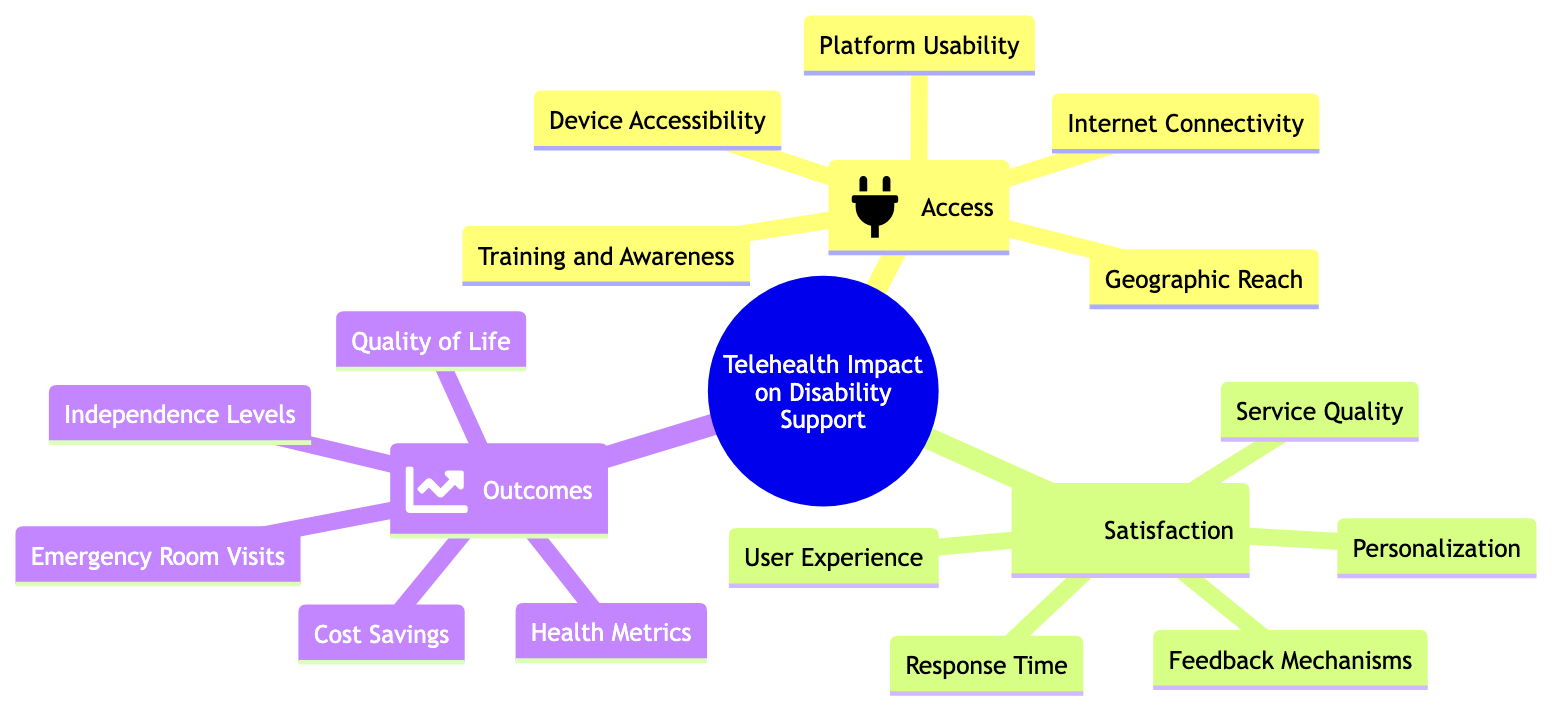What is the main topic of the mind map? The main topic is found at the root of the diagram, which states "Analyzing the Impact of Telehealth Solutions on Disability Support."
Answer: Analyzing the Impact of Telehealth Solutions on Disability Support How many subtopics are there under the main topic? There are three distinct subtopics branching from the main topic: "Access," "Satisfaction," and "Outcomes." Thus, by counting these subtopics, we determine there are three.
Answer: 3 What element is listed under the "Access" subtopic? Looking under the "Access" subtopic, the first element mentioned is "Internet Connectivity."
Answer: Internet Connectivity Which subtopic has the most elements listed? By examining each subtopic and counting their respective elements, we find that both "Access" and "Satisfaction" have five elements, while "Outcomes" has four. Therefore, "Access" and "Satisfaction" are tied for the most elements.
Answer: Access and Satisfaction What is the last element listed under the "Outcomes" subtopic? In the "Outcomes" section of the diagram, the last element listed is "Cost Savings."
Answer: Cost Savings How do "User Experience" and "Service Quality" relate in the satisfaction subtopic? Both "User Experience" and "Service Quality" are elements under the same subtopic "Satisfaction," indicating they are components contributing to the overall satisfaction level.
Answer: Related elements Why is "Training and Awareness" important in the "Access" section? "Training and Awareness" is crucial as it addresses the need for users to understand and effectively utilize telehealth solutions, enhancing user access and engagement with the services.
Answer: Important for user engagement What is the relationship between "Quality of Life" and "Health Metrics"? Both "Quality of Life" and "Health Metrics" are elements under the "Outcomes" subtopic, suggesting they are related in assessing the broad impact of telehealth on users' health and overall well-being.
Answer: Related elements in Outcomes 